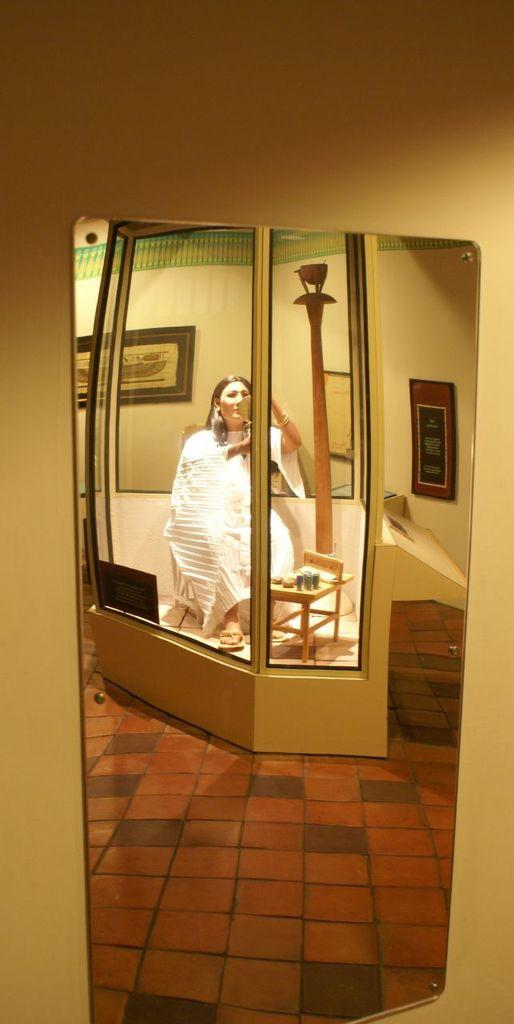What object is present in the image that can create reflections? There is a mirror in the image. What does the mirror reflect in the image? The mirror reflects a woman in the image. Besides the woman, what else can be seen in the mirror's reflection? There are paintings visible in the mirror's reflection. What type of credit card does the woman use to purchase the paintings in the image? There is no credit card or purchase of paintings mentioned or visible in the image. 